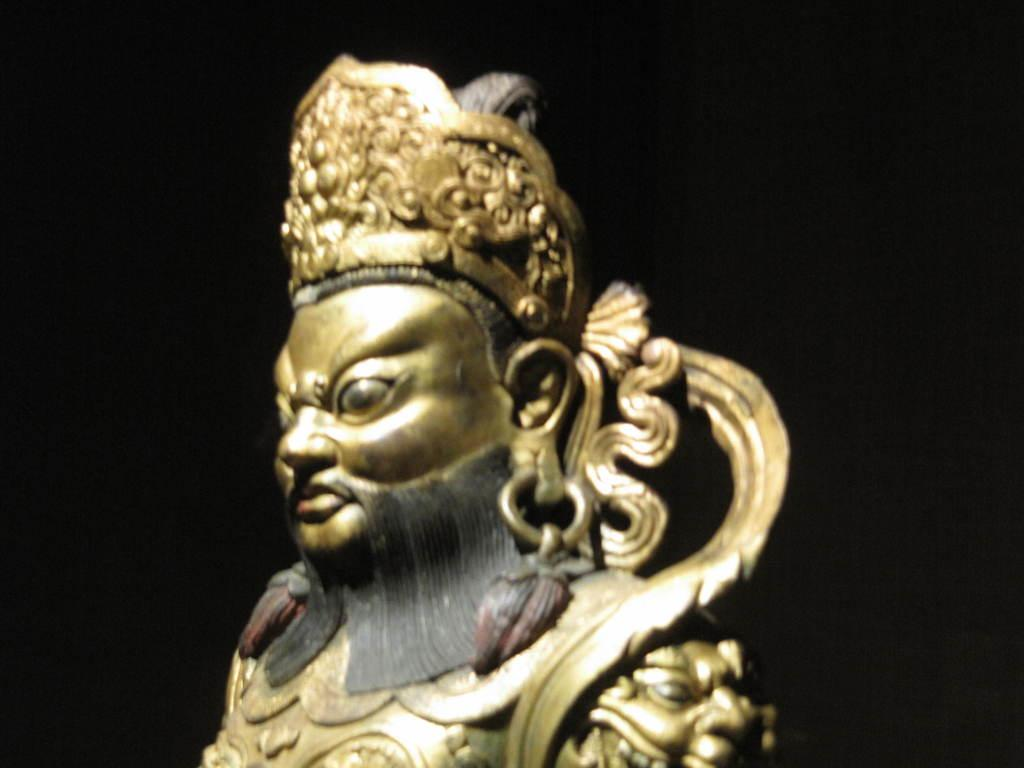What is the main subject in the image? There is a metal statue in the image. What can be observed about the background of the image? The background of the image is black. What type of lace can be seen draped over the statue in the image? There is no lace present in the image; it features a metal statue with a black background. 